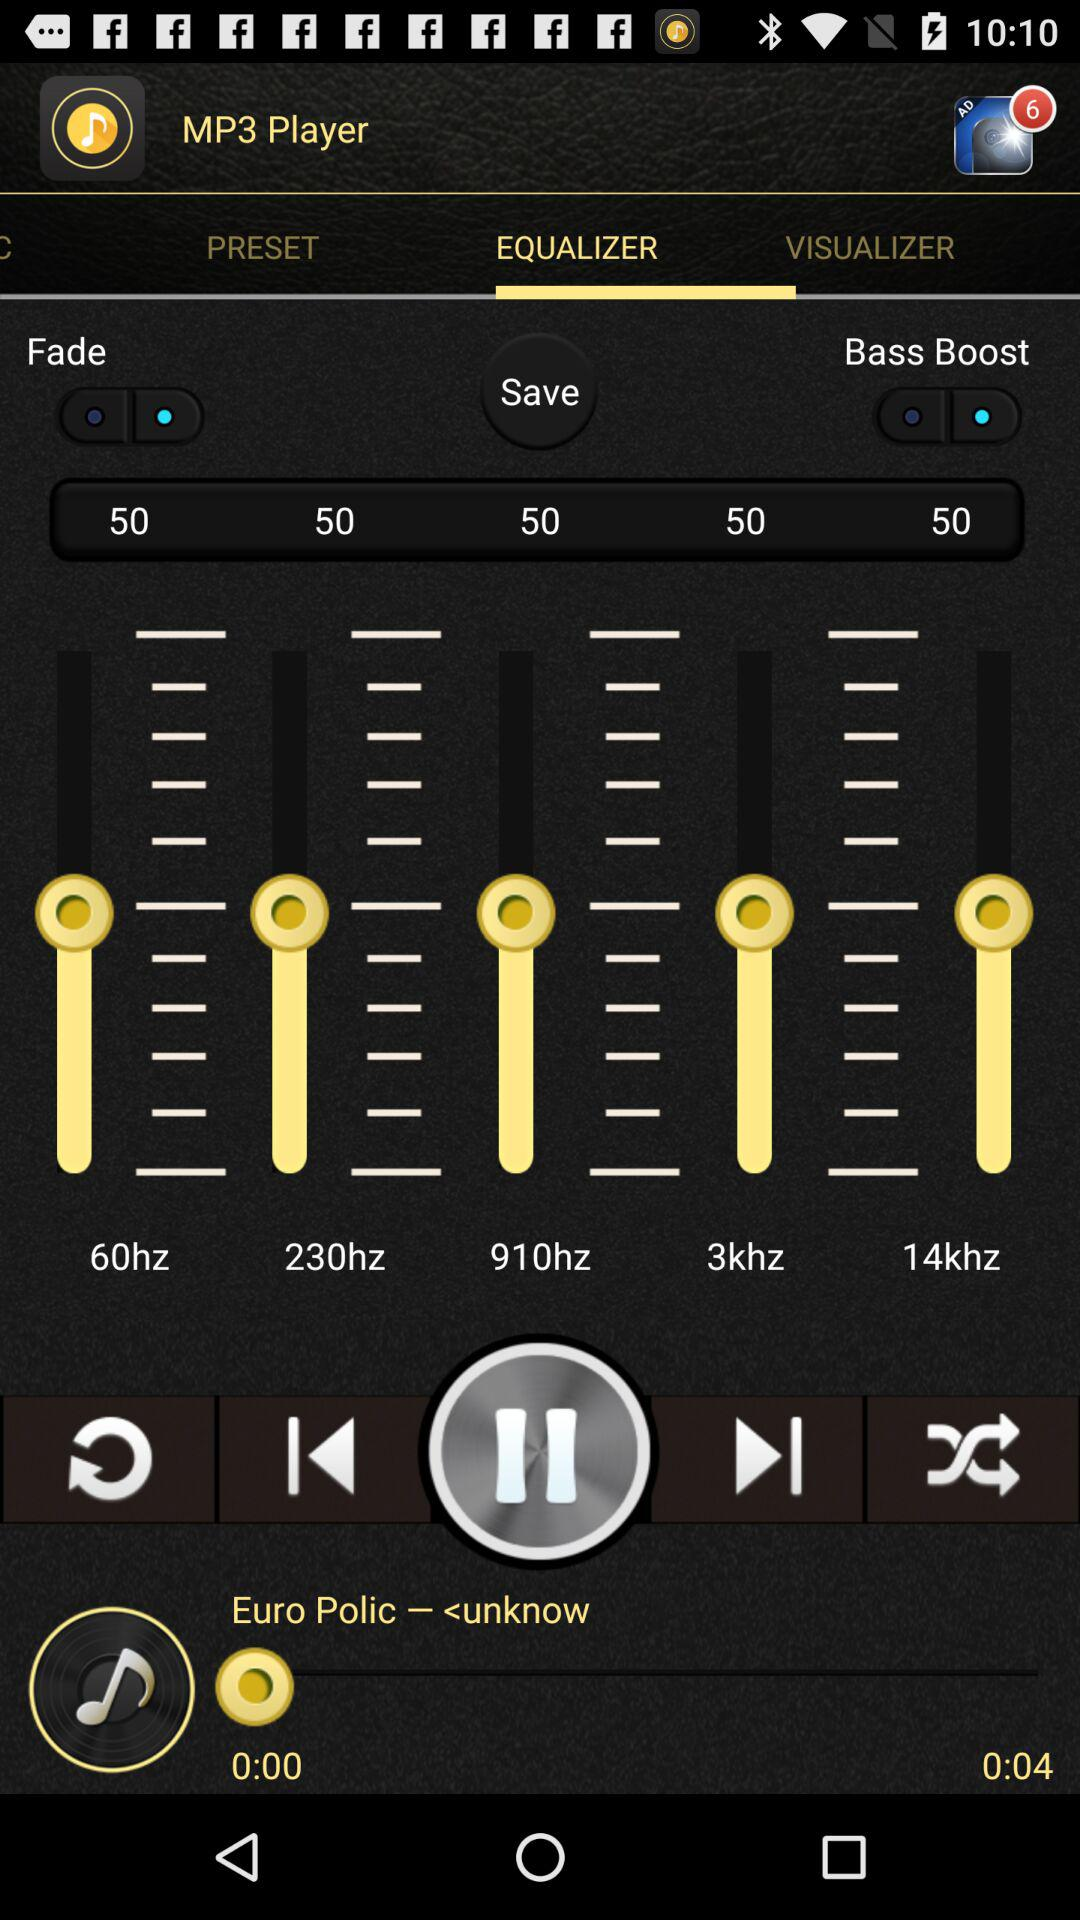What is the total duration of the audio? The total duration of the audio is 4 seconds. 